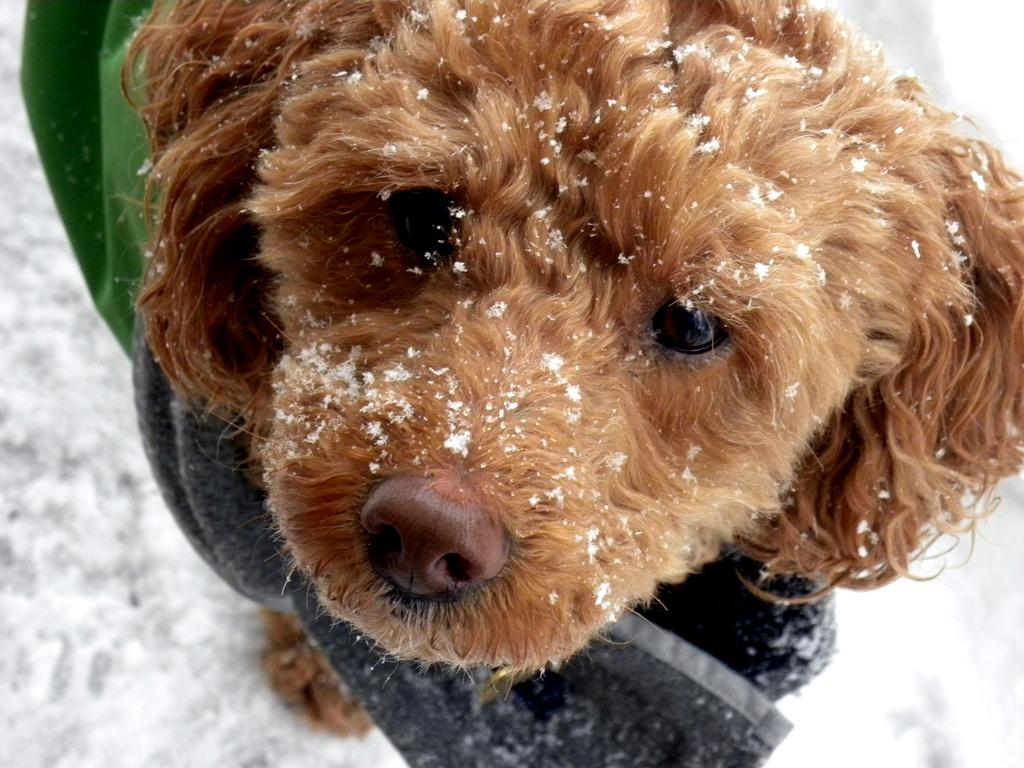What type of animal is in the image? There is a dog in the image. What color is the dog? The dog is brown in color. What can be seen in the background of the image? There is a green and black color cloth and snow visible in the image. What type of cap is the dog wearing in the image? There is no cap present on the dog in the image. Can you describe the dog's brain in the image? There is no information about the dog's brain in the image, as it is not visible or mentioned in the provided facts. 